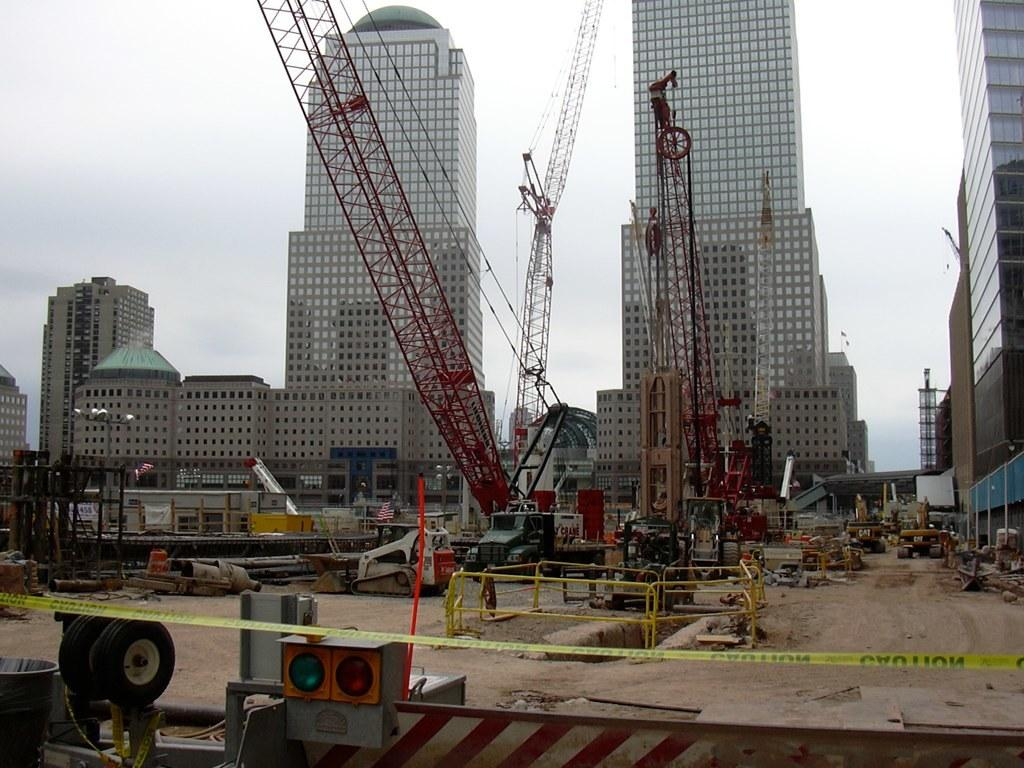What type of machinery is present in the image? There is a crane in the image. Where is the crane located? The crane is in a construction zone. What can be seen in the background of the image? There are buildings in the background of the image. What is the condition of the sky in the image? The sky is clear in the image. How many girls are holding a pot and a balloon in the image? There are no girls, pots, or balloons present in the image. 